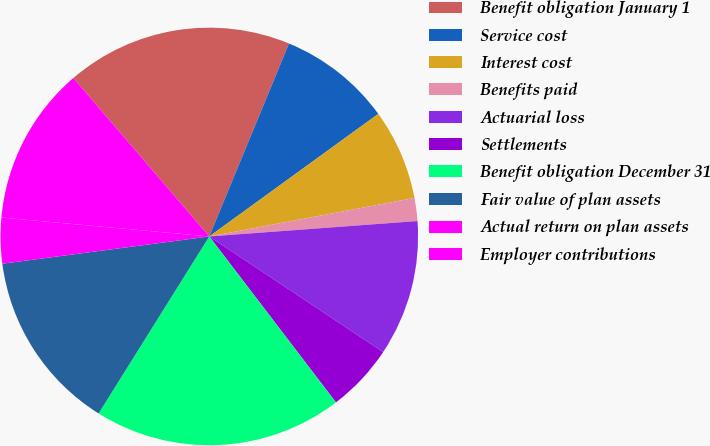Convert chart. <chart><loc_0><loc_0><loc_500><loc_500><pie_chart><fcel>Benefit obligation January 1<fcel>Service cost<fcel>Interest cost<fcel>Benefits paid<fcel>Actuarial loss<fcel>Settlements<fcel>Benefit obligation December 31<fcel>Fair value of plan assets<fcel>Actual return on plan assets<fcel>Employer contributions<nl><fcel>17.52%<fcel>8.78%<fcel>7.03%<fcel>1.78%<fcel>10.52%<fcel>5.28%<fcel>19.27%<fcel>14.02%<fcel>3.53%<fcel>12.27%<nl></chart> 